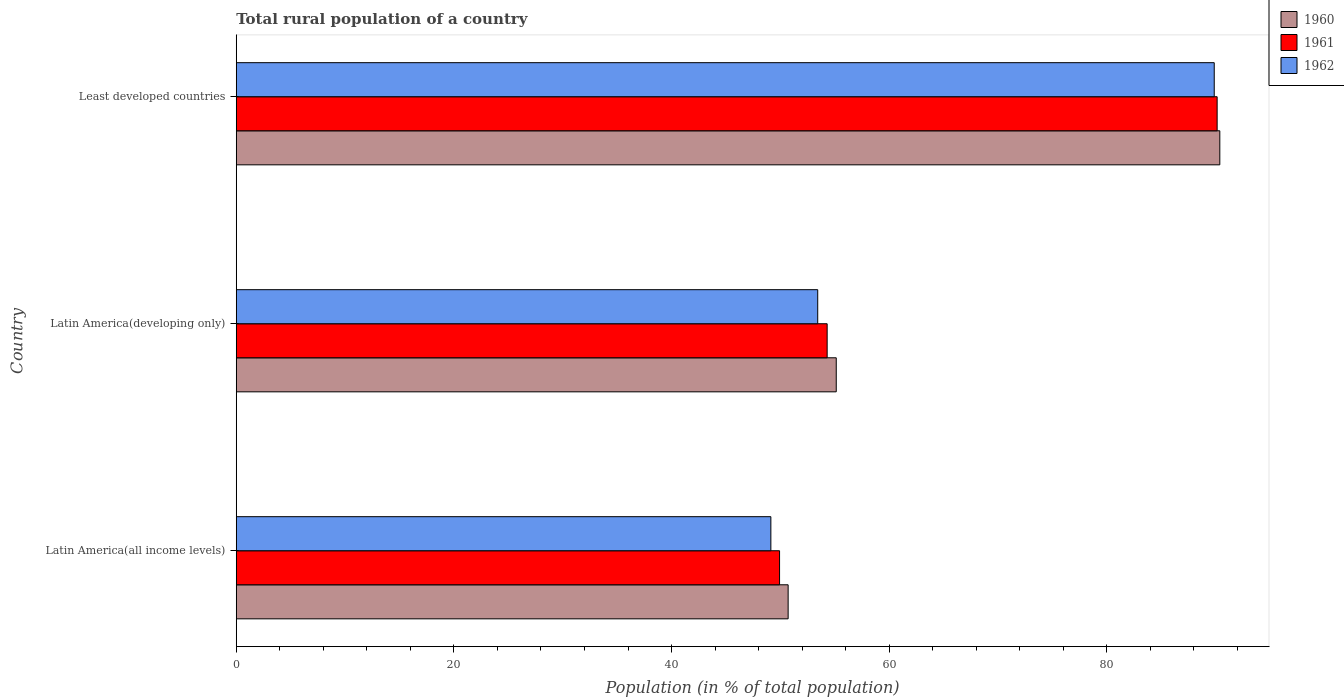How many groups of bars are there?
Your answer should be compact. 3. Are the number of bars on each tick of the Y-axis equal?
Make the answer very short. Yes. How many bars are there on the 2nd tick from the bottom?
Provide a succinct answer. 3. What is the label of the 2nd group of bars from the top?
Your response must be concise. Latin America(developing only). What is the rural population in 1962 in Latin America(all income levels)?
Ensure brevity in your answer.  49.13. Across all countries, what is the maximum rural population in 1961?
Make the answer very short. 90.14. Across all countries, what is the minimum rural population in 1961?
Make the answer very short. 49.93. In which country was the rural population in 1960 maximum?
Offer a terse response. Least developed countries. In which country was the rural population in 1960 minimum?
Your response must be concise. Latin America(all income levels). What is the total rural population in 1962 in the graph?
Provide a short and direct response. 192.43. What is the difference between the rural population in 1960 in Latin America(developing only) and that in Least developed countries?
Keep it short and to the point. -35.25. What is the difference between the rural population in 1961 in Latin America(all income levels) and the rural population in 1960 in Latin America(developing only)?
Your response must be concise. -5.21. What is the average rural population in 1961 per country?
Make the answer very short. 64.79. What is the difference between the rural population in 1960 and rural population in 1962 in Latin America(all income levels)?
Keep it short and to the point. 1.59. In how many countries, is the rural population in 1961 greater than 52 %?
Give a very brief answer. 2. What is the ratio of the rural population in 1962 in Latin America(all income levels) to that in Latin America(developing only)?
Offer a very short reply. 0.92. Is the difference between the rural population in 1960 in Latin America(all income levels) and Least developed countries greater than the difference between the rural population in 1962 in Latin America(all income levels) and Least developed countries?
Your answer should be very brief. Yes. What is the difference between the highest and the second highest rural population in 1960?
Your response must be concise. 35.25. What is the difference between the highest and the lowest rural population in 1960?
Your answer should be compact. 39.67. In how many countries, is the rural population in 1962 greater than the average rural population in 1962 taken over all countries?
Offer a terse response. 1. Is the sum of the rural population in 1962 in Latin America(developing only) and Least developed countries greater than the maximum rural population in 1960 across all countries?
Make the answer very short. Yes. What does the 2nd bar from the top in Latin America(developing only) represents?
Provide a succinct answer. 1961. What does the 2nd bar from the bottom in Latin America(developing only) represents?
Provide a short and direct response. 1961. How many bars are there?
Offer a very short reply. 9. How many countries are there in the graph?
Your response must be concise. 3. Are the values on the major ticks of X-axis written in scientific E-notation?
Give a very brief answer. No. Does the graph contain any zero values?
Keep it short and to the point. No. Does the graph contain grids?
Provide a succinct answer. No. How many legend labels are there?
Provide a short and direct response. 3. How are the legend labels stacked?
Provide a succinct answer. Vertical. What is the title of the graph?
Offer a very short reply. Total rural population of a country. Does "1997" appear as one of the legend labels in the graph?
Give a very brief answer. No. What is the label or title of the X-axis?
Provide a short and direct response. Population (in % of total population). What is the label or title of the Y-axis?
Provide a short and direct response. Country. What is the Population (in % of total population) of 1960 in Latin America(all income levels)?
Your answer should be compact. 50.72. What is the Population (in % of total population) of 1961 in Latin America(all income levels)?
Ensure brevity in your answer.  49.93. What is the Population (in % of total population) of 1962 in Latin America(all income levels)?
Give a very brief answer. 49.13. What is the Population (in % of total population) of 1960 in Latin America(developing only)?
Make the answer very short. 55.14. What is the Population (in % of total population) of 1961 in Latin America(developing only)?
Provide a succinct answer. 54.3. What is the Population (in % of total population) of 1962 in Latin America(developing only)?
Provide a short and direct response. 53.43. What is the Population (in % of total population) of 1960 in Least developed countries?
Provide a succinct answer. 90.38. What is the Population (in % of total population) of 1961 in Least developed countries?
Give a very brief answer. 90.14. What is the Population (in % of total population) of 1962 in Least developed countries?
Offer a very short reply. 89.87. Across all countries, what is the maximum Population (in % of total population) in 1960?
Keep it short and to the point. 90.38. Across all countries, what is the maximum Population (in % of total population) of 1961?
Your answer should be compact. 90.14. Across all countries, what is the maximum Population (in % of total population) in 1962?
Your answer should be compact. 89.87. Across all countries, what is the minimum Population (in % of total population) of 1960?
Make the answer very short. 50.72. Across all countries, what is the minimum Population (in % of total population) of 1961?
Provide a succinct answer. 49.93. Across all countries, what is the minimum Population (in % of total population) of 1962?
Keep it short and to the point. 49.13. What is the total Population (in % of total population) of 1960 in the graph?
Provide a succinct answer. 196.24. What is the total Population (in % of total population) in 1961 in the graph?
Your response must be concise. 194.36. What is the total Population (in % of total population) of 1962 in the graph?
Make the answer very short. 192.43. What is the difference between the Population (in % of total population) in 1960 in Latin America(all income levels) and that in Latin America(developing only)?
Offer a terse response. -4.42. What is the difference between the Population (in % of total population) in 1961 in Latin America(all income levels) and that in Latin America(developing only)?
Provide a succinct answer. -4.37. What is the difference between the Population (in % of total population) of 1962 in Latin America(all income levels) and that in Latin America(developing only)?
Provide a succinct answer. -4.31. What is the difference between the Population (in % of total population) of 1960 in Latin America(all income levels) and that in Least developed countries?
Ensure brevity in your answer.  -39.67. What is the difference between the Population (in % of total population) of 1961 in Latin America(all income levels) and that in Least developed countries?
Make the answer very short. -40.21. What is the difference between the Population (in % of total population) of 1962 in Latin America(all income levels) and that in Least developed countries?
Make the answer very short. -40.74. What is the difference between the Population (in % of total population) of 1960 in Latin America(developing only) and that in Least developed countries?
Your answer should be compact. -35.25. What is the difference between the Population (in % of total population) in 1961 in Latin America(developing only) and that in Least developed countries?
Make the answer very short. -35.84. What is the difference between the Population (in % of total population) of 1962 in Latin America(developing only) and that in Least developed countries?
Your response must be concise. -36.44. What is the difference between the Population (in % of total population) of 1960 in Latin America(all income levels) and the Population (in % of total population) of 1961 in Latin America(developing only)?
Keep it short and to the point. -3.58. What is the difference between the Population (in % of total population) in 1960 in Latin America(all income levels) and the Population (in % of total population) in 1962 in Latin America(developing only)?
Provide a short and direct response. -2.72. What is the difference between the Population (in % of total population) in 1961 in Latin America(all income levels) and the Population (in % of total population) in 1962 in Latin America(developing only)?
Make the answer very short. -3.51. What is the difference between the Population (in % of total population) in 1960 in Latin America(all income levels) and the Population (in % of total population) in 1961 in Least developed countries?
Provide a short and direct response. -39.42. What is the difference between the Population (in % of total population) of 1960 in Latin America(all income levels) and the Population (in % of total population) of 1962 in Least developed countries?
Keep it short and to the point. -39.16. What is the difference between the Population (in % of total population) in 1961 in Latin America(all income levels) and the Population (in % of total population) in 1962 in Least developed countries?
Provide a short and direct response. -39.94. What is the difference between the Population (in % of total population) in 1960 in Latin America(developing only) and the Population (in % of total population) in 1961 in Least developed countries?
Your answer should be very brief. -35. What is the difference between the Population (in % of total population) of 1960 in Latin America(developing only) and the Population (in % of total population) of 1962 in Least developed countries?
Ensure brevity in your answer.  -34.73. What is the difference between the Population (in % of total population) in 1961 in Latin America(developing only) and the Population (in % of total population) in 1962 in Least developed countries?
Make the answer very short. -35.57. What is the average Population (in % of total population) of 1960 per country?
Your response must be concise. 65.41. What is the average Population (in % of total population) of 1961 per country?
Make the answer very short. 64.79. What is the average Population (in % of total population) of 1962 per country?
Ensure brevity in your answer.  64.14. What is the difference between the Population (in % of total population) in 1960 and Population (in % of total population) in 1961 in Latin America(all income levels)?
Your answer should be very brief. 0.79. What is the difference between the Population (in % of total population) of 1960 and Population (in % of total population) of 1962 in Latin America(all income levels)?
Make the answer very short. 1.59. What is the difference between the Population (in % of total population) of 1961 and Population (in % of total population) of 1962 in Latin America(all income levels)?
Ensure brevity in your answer.  0.8. What is the difference between the Population (in % of total population) of 1960 and Population (in % of total population) of 1961 in Latin America(developing only)?
Your response must be concise. 0.84. What is the difference between the Population (in % of total population) of 1960 and Population (in % of total population) of 1962 in Latin America(developing only)?
Your answer should be compact. 1.7. What is the difference between the Population (in % of total population) of 1961 and Population (in % of total population) of 1962 in Latin America(developing only)?
Make the answer very short. 0.87. What is the difference between the Population (in % of total population) of 1960 and Population (in % of total population) of 1961 in Least developed countries?
Your answer should be very brief. 0.25. What is the difference between the Population (in % of total population) of 1960 and Population (in % of total population) of 1962 in Least developed countries?
Offer a very short reply. 0.51. What is the difference between the Population (in % of total population) in 1961 and Population (in % of total population) in 1962 in Least developed countries?
Keep it short and to the point. 0.27. What is the ratio of the Population (in % of total population) in 1960 in Latin America(all income levels) to that in Latin America(developing only)?
Your answer should be very brief. 0.92. What is the ratio of the Population (in % of total population) in 1961 in Latin America(all income levels) to that in Latin America(developing only)?
Offer a very short reply. 0.92. What is the ratio of the Population (in % of total population) of 1962 in Latin America(all income levels) to that in Latin America(developing only)?
Provide a short and direct response. 0.92. What is the ratio of the Population (in % of total population) of 1960 in Latin America(all income levels) to that in Least developed countries?
Give a very brief answer. 0.56. What is the ratio of the Population (in % of total population) of 1961 in Latin America(all income levels) to that in Least developed countries?
Your response must be concise. 0.55. What is the ratio of the Population (in % of total population) in 1962 in Latin America(all income levels) to that in Least developed countries?
Your answer should be very brief. 0.55. What is the ratio of the Population (in % of total population) in 1960 in Latin America(developing only) to that in Least developed countries?
Offer a terse response. 0.61. What is the ratio of the Population (in % of total population) in 1961 in Latin America(developing only) to that in Least developed countries?
Offer a very short reply. 0.6. What is the ratio of the Population (in % of total population) in 1962 in Latin America(developing only) to that in Least developed countries?
Your answer should be compact. 0.59. What is the difference between the highest and the second highest Population (in % of total population) of 1960?
Offer a terse response. 35.25. What is the difference between the highest and the second highest Population (in % of total population) in 1961?
Your answer should be very brief. 35.84. What is the difference between the highest and the second highest Population (in % of total population) in 1962?
Offer a very short reply. 36.44. What is the difference between the highest and the lowest Population (in % of total population) of 1960?
Give a very brief answer. 39.67. What is the difference between the highest and the lowest Population (in % of total population) in 1961?
Make the answer very short. 40.21. What is the difference between the highest and the lowest Population (in % of total population) in 1962?
Ensure brevity in your answer.  40.74. 